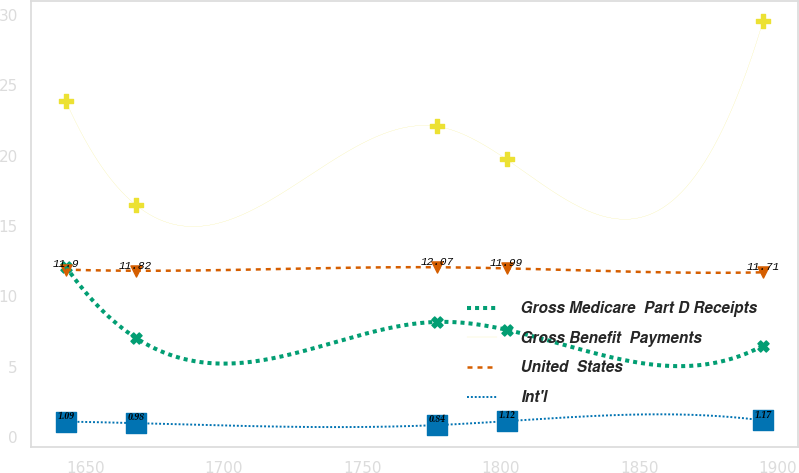Convert chart to OTSL. <chart><loc_0><loc_0><loc_500><loc_500><line_chart><ecel><fcel>Gross Medicare  Part D Receipts<fcel>Gross Benefit  Payments<fcel>United  States<fcel>Int'l<nl><fcel>1642.9<fcel>12.12<fcel>23.89<fcel>11.9<fcel>1.09<nl><fcel>1668.09<fcel>7.06<fcel>16.52<fcel>11.82<fcel>0.98<nl><fcel>1776.95<fcel>8.18<fcel>22.09<fcel>12.07<fcel>0.84<nl><fcel>1802.14<fcel>7.62<fcel>19.74<fcel>11.99<fcel>1.12<nl><fcel>1894.81<fcel>6.5<fcel>29.6<fcel>11.71<fcel>1.17<nl></chart> 